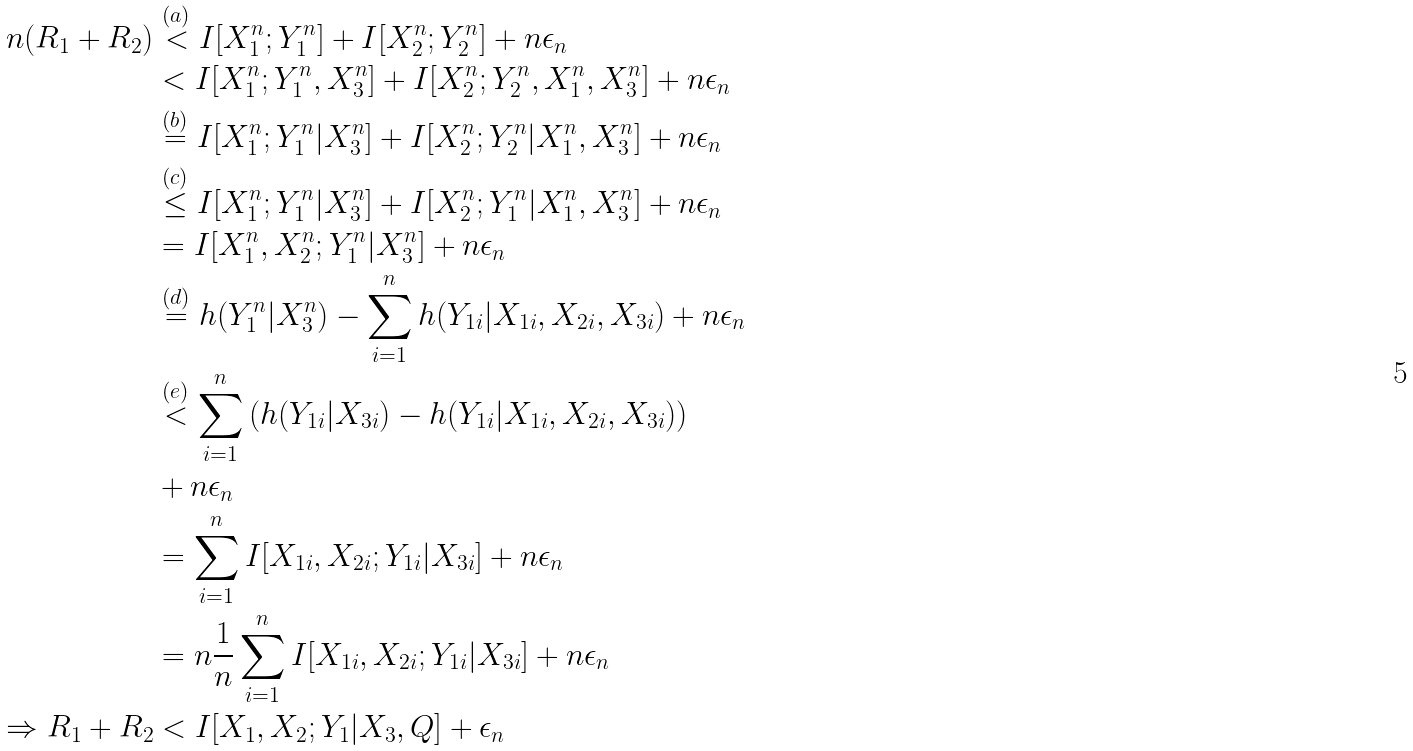<formula> <loc_0><loc_0><loc_500><loc_500>n ( R _ { 1 } + R _ { 2 } ) & \stackrel { ( a ) } { < } I [ X _ { 1 } ^ { n } ; Y _ { 1 } ^ { n } ] + I [ X _ { 2 } ^ { n } ; Y _ { 2 } ^ { n } ] + n \epsilon _ { n } \\ & < I [ X _ { 1 } ^ { n } ; Y _ { 1 } ^ { n } , X _ { 3 } ^ { n } ] + I [ X _ { 2 } ^ { n } ; Y _ { 2 } ^ { n } , X _ { 1 } ^ { n } , X _ { 3 } ^ { n } ] + n \epsilon _ { n } \\ & \stackrel { ( b ) } { = } I [ X _ { 1 } ^ { n } ; Y _ { 1 } ^ { n } | X _ { 3 } ^ { n } ] + I [ X _ { 2 } ^ { n } ; Y _ { 2 } ^ { n } | X _ { 1 } ^ { n } , X _ { 3 } ^ { n } ] + n \epsilon _ { n } \\ & \stackrel { ( c ) } { \leq } I [ X _ { 1 } ^ { n } ; Y _ { 1 } ^ { n } | X _ { 3 } ^ { n } ] + I [ X _ { 2 } ^ { n } ; Y _ { 1 } ^ { n } | X _ { 1 } ^ { n } , X _ { 3 } ^ { n } ] + n \epsilon _ { n } \\ & = I [ X _ { 1 } ^ { n } , X _ { 2 } ^ { n } ; Y _ { 1 } ^ { n } | X _ { 3 } ^ { n } ] + n \epsilon _ { n } \\ & \stackrel { ( d ) } { = } h ( Y _ { 1 } ^ { n } | X _ { 3 } ^ { n } ) - \sum _ { i = 1 } ^ { n } h ( Y _ { 1 i } | X _ { 1 i } , X _ { 2 i } , X _ { 3 i } ) + n \epsilon _ { n } \\ & \stackrel { ( e ) } { < } \sum _ { i = 1 } ^ { n } \left ( h ( Y _ { 1 i } | X _ { 3 i } ) - h ( Y _ { 1 i } | X _ { 1 i } , X _ { 2 i } , X _ { 3 i } ) \right ) \\ & + n \epsilon _ { n } \\ & = \sum _ { i = 1 } ^ { n } I [ X _ { 1 i } , X _ { 2 i } ; Y _ { 1 i } | X _ { 3 i } ] + n \epsilon _ { n } \\ & = n \frac { 1 } { n } \sum _ { i = 1 } ^ { n } I [ X _ { 1 i } , X _ { 2 i } ; Y _ { 1 i } | X _ { 3 i } ] + n \epsilon _ { n } \\ \Rightarrow R _ { 1 } + R _ { 2 } & < I [ X _ { 1 } , X _ { 2 } ; Y _ { 1 } | X _ { 3 } , Q ] + \epsilon _ { n }</formula> 